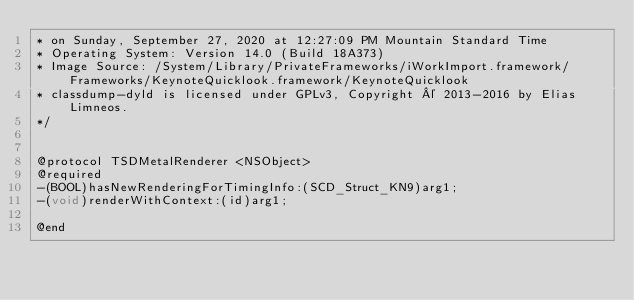Convert code to text. <code><loc_0><loc_0><loc_500><loc_500><_C_>* on Sunday, September 27, 2020 at 12:27:09 PM Mountain Standard Time
* Operating System: Version 14.0 (Build 18A373)
* Image Source: /System/Library/PrivateFrameworks/iWorkImport.framework/Frameworks/KeynoteQuicklook.framework/KeynoteQuicklook
* classdump-dyld is licensed under GPLv3, Copyright © 2013-2016 by Elias Limneos.
*/


@protocol TSDMetalRenderer <NSObject>
@required
-(BOOL)hasNewRenderingForTimingInfo:(SCD_Struct_KN9)arg1;
-(void)renderWithContext:(id)arg1;

@end

</code> 